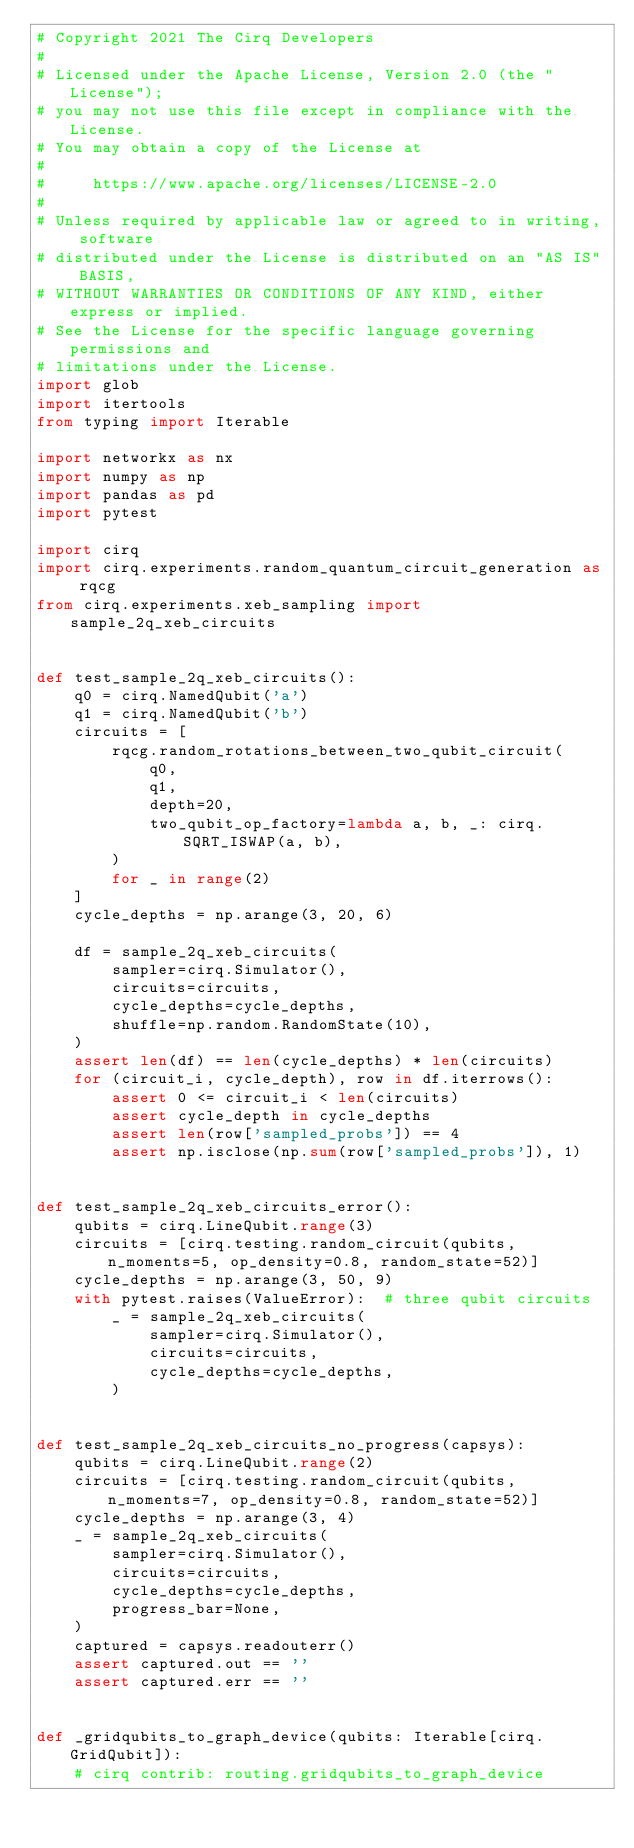<code> <loc_0><loc_0><loc_500><loc_500><_Python_># Copyright 2021 The Cirq Developers
#
# Licensed under the Apache License, Version 2.0 (the "License");
# you may not use this file except in compliance with the License.
# You may obtain a copy of the License at
#
#     https://www.apache.org/licenses/LICENSE-2.0
#
# Unless required by applicable law or agreed to in writing, software
# distributed under the License is distributed on an "AS IS" BASIS,
# WITHOUT WARRANTIES OR CONDITIONS OF ANY KIND, either express or implied.
# See the License for the specific language governing permissions and
# limitations under the License.
import glob
import itertools
from typing import Iterable

import networkx as nx
import numpy as np
import pandas as pd
import pytest

import cirq
import cirq.experiments.random_quantum_circuit_generation as rqcg
from cirq.experiments.xeb_sampling import sample_2q_xeb_circuits


def test_sample_2q_xeb_circuits():
    q0 = cirq.NamedQubit('a')
    q1 = cirq.NamedQubit('b')
    circuits = [
        rqcg.random_rotations_between_two_qubit_circuit(
            q0,
            q1,
            depth=20,
            two_qubit_op_factory=lambda a, b, _: cirq.SQRT_ISWAP(a, b),
        )
        for _ in range(2)
    ]
    cycle_depths = np.arange(3, 20, 6)

    df = sample_2q_xeb_circuits(
        sampler=cirq.Simulator(),
        circuits=circuits,
        cycle_depths=cycle_depths,
        shuffle=np.random.RandomState(10),
    )
    assert len(df) == len(cycle_depths) * len(circuits)
    for (circuit_i, cycle_depth), row in df.iterrows():
        assert 0 <= circuit_i < len(circuits)
        assert cycle_depth in cycle_depths
        assert len(row['sampled_probs']) == 4
        assert np.isclose(np.sum(row['sampled_probs']), 1)


def test_sample_2q_xeb_circuits_error():
    qubits = cirq.LineQubit.range(3)
    circuits = [cirq.testing.random_circuit(qubits, n_moments=5, op_density=0.8, random_state=52)]
    cycle_depths = np.arange(3, 50, 9)
    with pytest.raises(ValueError):  # three qubit circuits
        _ = sample_2q_xeb_circuits(
            sampler=cirq.Simulator(),
            circuits=circuits,
            cycle_depths=cycle_depths,
        )


def test_sample_2q_xeb_circuits_no_progress(capsys):
    qubits = cirq.LineQubit.range(2)
    circuits = [cirq.testing.random_circuit(qubits, n_moments=7, op_density=0.8, random_state=52)]
    cycle_depths = np.arange(3, 4)
    _ = sample_2q_xeb_circuits(
        sampler=cirq.Simulator(),
        circuits=circuits,
        cycle_depths=cycle_depths,
        progress_bar=None,
    )
    captured = capsys.readouterr()
    assert captured.out == ''
    assert captured.err == ''


def _gridqubits_to_graph_device(qubits: Iterable[cirq.GridQubit]):
    # cirq contrib: routing.gridqubits_to_graph_device</code> 